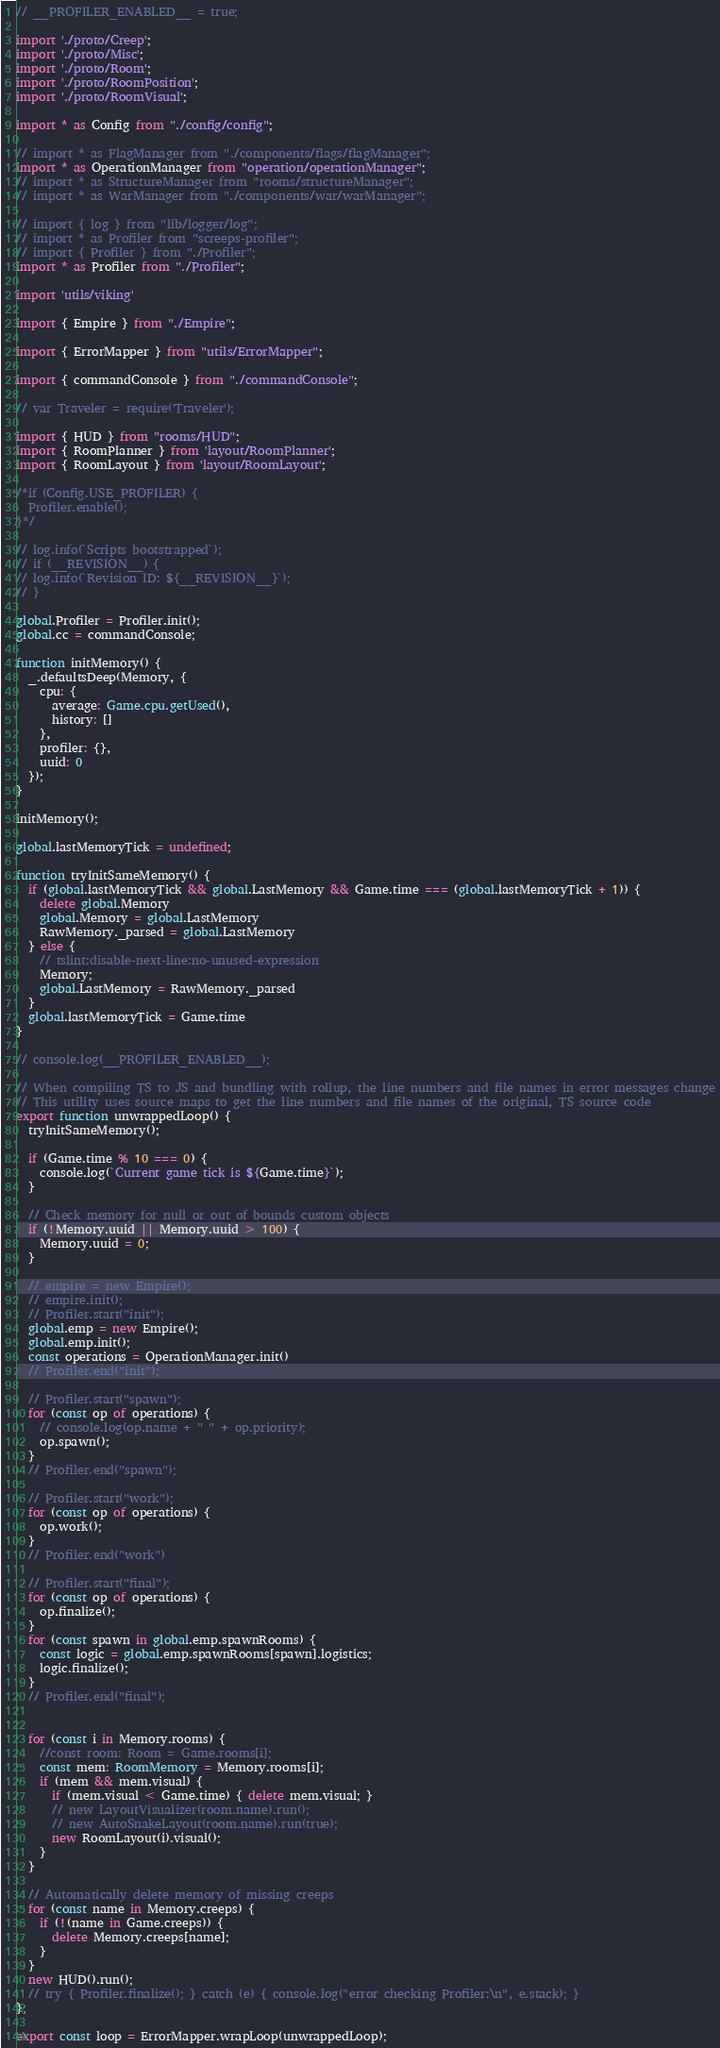<code> <loc_0><loc_0><loc_500><loc_500><_TypeScript_>// __PROFILER_ENABLED__ = true;

import './proto/Creep';
import './proto/Misc';
import './proto/Room';
import './proto/RoomPosition';
import './proto/RoomVisual';

import * as Config from "./config/config";

// import * as FlagManager from "./components/flags/flagManager";
import * as OperationManager from "operation/operationManager";
// import * as StructureManager from "rooms/structureManager";
// import * as WarManager from "./components/war/warManager";

// import { log } from "lib/logger/log";
// import * as Profiler from "screeps-profiler";
// import { Profiler } from "./Profiler";
import * as Profiler from "./Profiler";

import 'utils/viking'

import { Empire } from "./Empire";

import { ErrorMapper } from "utils/ErrorMapper";

import { commandConsole } from "./commandConsole";

// var Traveler = require('Traveler');

import { HUD } from "rooms/HUD";
import { RoomPlanner } from 'layout/RoomPlanner';
import { RoomLayout } from 'layout/RoomLayout';

/*if (Config.USE_PROFILER) {
  Profiler.enable();
}*/

// log.info(`Scripts bootstrapped`);
// if (__REVISION__) {
// log.info(`Revision ID: ${__REVISION__}`);
// }

global.Profiler = Profiler.init();
global.cc = commandConsole;

function initMemory() {
  _.defaultsDeep(Memory, {
    cpu: {
      average: Game.cpu.getUsed(),
      history: []
    },
    profiler: {},
    uuid: 0
  });
}

initMemory();

global.lastMemoryTick = undefined;

function tryInitSameMemory() {
  if (global.lastMemoryTick && global.LastMemory && Game.time === (global.lastMemoryTick + 1)) {
    delete global.Memory
    global.Memory = global.LastMemory
    RawMemory._parsed = global.LastMemory
  } else {
    // tslint:disable-next-line:no-unused-expression
    Memory;
    global.LastMemory = RawMemory._parsed
  }
  global.lastMemoryTick = Game.time
}

// console.log(__PROFILER_ENABLED__);

// When compiling TS to JS and bundling with rollup, the line numbers and file names in error messages change
// This utility uses source maps to get the line numbers and file names of the original, TS source code
export function unwrappedLoop() {
  tryInitSameMemory();

  if (Game.time % 10 === 0) {
    console.log(`Current game tick is ${Game.time}`);
  }

  // Check memory for null or out of bounds custom objects
  if (!Memory.uuid || Memory.uuid > 100) {
    Memory.uuid = 0;
  }

  // empire = new Empire();
  // empire.init();
  // Profiler.start("init");
  global.emp = new Empire();
  global.emp.init();
  const operations = OperationManager.init()
  // Profiler.end("init");

  // Profiler.start("spawn");
  for (const op of operations) {
    // console.log(op.name + " " + op.priority);
    op.spawn();
  }
  // Profiler.end("spawn");

  // Profiler.start("work");
  for (const op of operations) {
    op.work();
  }
  // Profiler.end("work")

  // Profiler.start("final");
  for (const op of operations) {
    op.finalize();
  }
  for (const spawn in global.emp.spawnRooms) {
    const logic = global.emp.spawnRooms[spawn].logistics;
    logic.finalize();
  }
  // Profiler.end("final");


  for (const i in Memory.rooms) {
    //const room: Room = Game.rooms[i];
    const mem: RoomMemory = Memory.rooms[i];
    if (mem && mem.visual) {
      if (mem.visual < Game.time) { delete mem.visual; }
      // new LayoutVisualizer(room.name).run();
      // new AutoSnakeLayout(room.name).run(true);
      new RoomLayout(i).visual();
    }
  }

  // Automatically delete memory of missing creeps
  for (const name in Memory.creeps) {
    if (!(name in Game.creeps)) {
      delete Memory.creeps[name];
    }
  }
  new HUD().run();
  // try { Profiler.finalize(); } catch (e) { console.log("error checking Profiler:\n", e.stack); }
};

export const loop = ErrorMapper.wrapLoop(unwrappedLoop);
</code> 